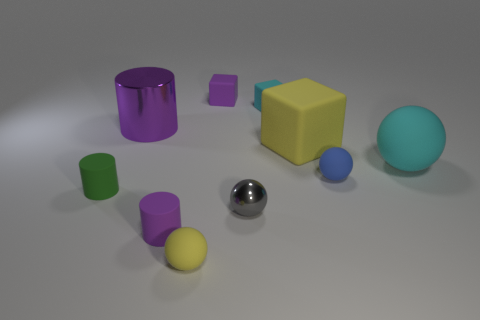Are there any big cyan metallic balls?
Your answer should be very brief. No. There is a tiny yellow object; are there any small balls behind it?
Provide a short and direct response. Yes. There is another purple object that is the same shape as the large purple object; what material is it?
Ensure brevity in your answer.  Rubber. What number of other objects are there of the same shape as the large purple thing?
Provide a succinct answer. 2. How many large yellow things are to the left of the rubber ball left of the tiny purple object that is behind the large metal object?
Give a very brief answer. 0. How many small purple matte objects are the same shape as the blue object?
Make the answer very short. 0. Is the color of the small matte block on the right side of the purple block the same as the large sphere?
Give a very brief answer. Yes. There is a purple matte thing that is in front of the cylinder behind the large matte thing that is on the right side of the big yellow thing; what shape is it?
Keep it short and to the point. Cylinder. There is a gray shiny ball; does it have the same size as the cylinder behind the large cyan rubber ball?
Your response must be concise. No. Is there a cylinder of the same size as the yellow rubber block?
Keep it short and to the point. Yes. 